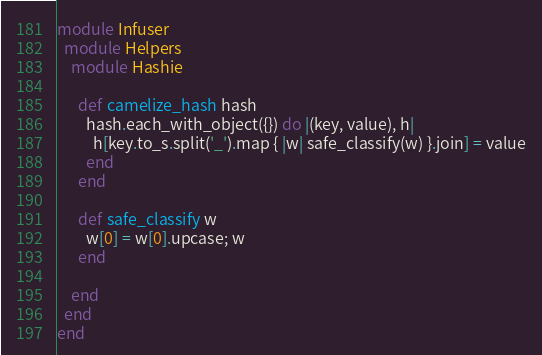<code> <loc_0><loc_0><loc_500><loc_500><_Ruby_>module Infuser
  module Helpers
    module Hashie

      def camelize_hash hash
        hash.each_with_object({}) do |(key, value), h|
          h[key.to_s.split('_').map { |w| safe_classify(w) }.join] = value
        end
      end

      def safe_classify w
        w[0] = w[0].upcase; w
      end

    end
  end
end</code> 